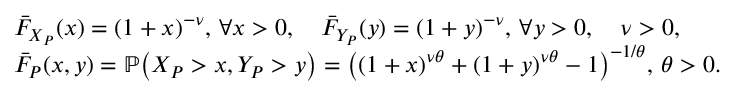Convert formula to latex. <formula><loc_0><loc_0><loc_500><loc_500>\begin{array} { r l } & { \bar { F } _ { X _ { P } } ( x ) = { ( 1 + x ) } ^ { - \nu } , \, \forall x > 0 , \quad \bar { F } _ { Y _ { P } } ( y ) = { ( 1 + y ) } ^ { - \nu } , \, \forall y > 0 , \quad \nu > 0 , } \\ & { \bar { F } _ { P } ( x , y ) = \mathbb { P } \, \left ( X _ { P } > x , Y _ { P } > y \right ) = { \left ( { ( 1 + x ) } ^ { \nu \theta } + { ( 1 + y ) } ^ { \nu \theta } - 1 \right ) } ^ { - 1 / \theta } , \, \theta > 0 . } \end{array}</formula> 